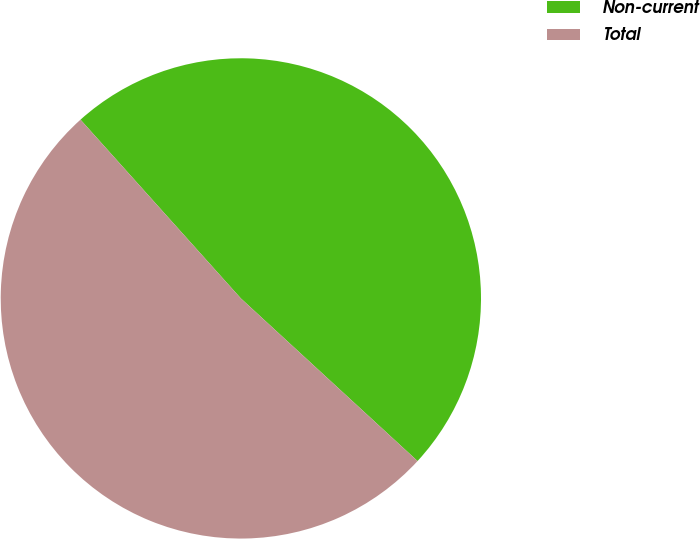<chart> <loc_0><loc_0><loc_500><loc_500><pie_chart><fcel>Non-current<fcel>Total<nl><fcel>48.48%<fcel>51.52%<nl></chart> 